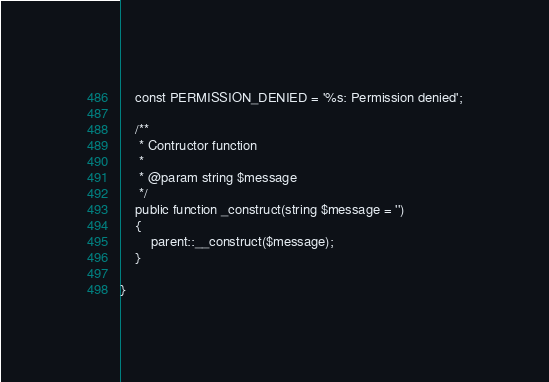<code> <loc_0><loc_0><loc_500><loc_500><_PHP_>    const PERMISSION_DENIED = '%s: Permission denied';
    
    /**
     * Contructor function 
     * 
     * @param string $message
     */
    public function _construct(string $message = '')
    {
        parent::__construct($message);
    }

} </code> 